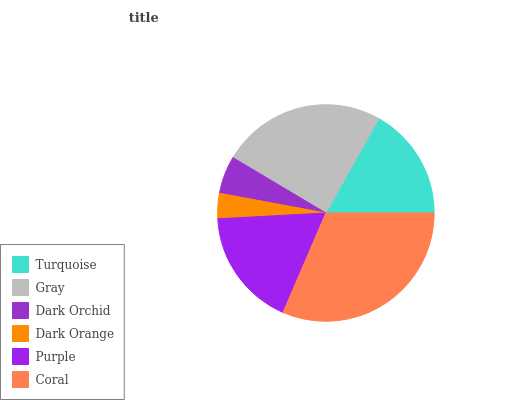Is Dark Orange the minimum?
Answer yes or no. Yes. Is Coral the maximum?
Answer yes or no. Yes. Is Gray the minimum?
Answer yes or no. No. Is Gray the maximum?
Answer yes or no. No. Is Gray greater than Turquoise?
Answer yes or no. Yes. Is Turquoise less than Gray?
Answer yes or no. Yes. Is Turquoise greater than Gray?
Answer yes or no. No. Is Gray less than Turquoise?
Answer yes or no. No. Is Purple the high median?
Answer yes or no. Yes. Is Turquoise the low median?
Answer yes or no. Yes. Is Turquoise the high median?
Answer yes or no. No. Is Dark Orange the low median?
Answer yes or no. No. 